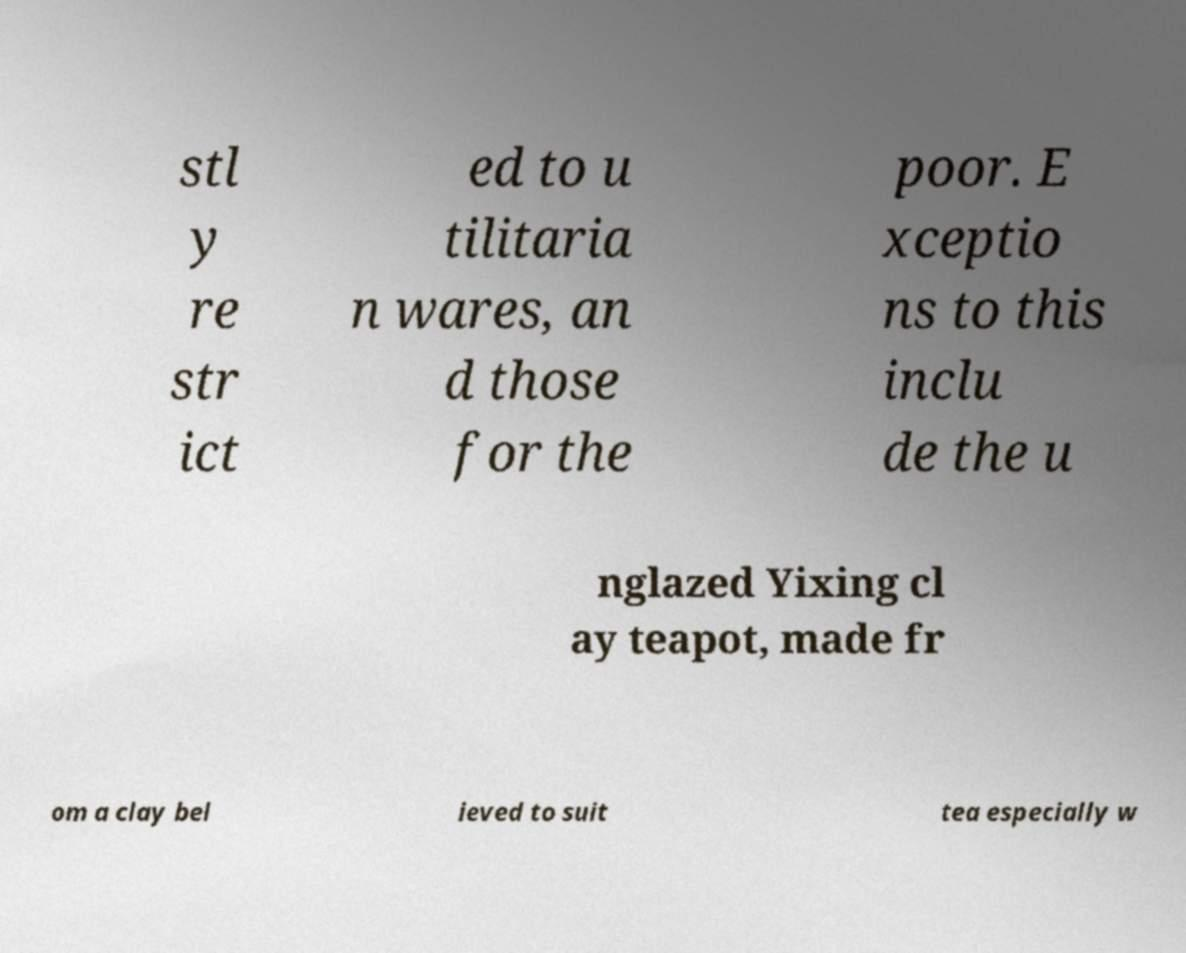Can you accurately transcribe the text from the provided image for me? stl y re str ict ed to u tilitaria n wares, an d those for the poor. E xceptio ns to this inclu de the u nglazed Yixing cl ay teapot, made fr om a clay bel ieved to suit tea especially w 